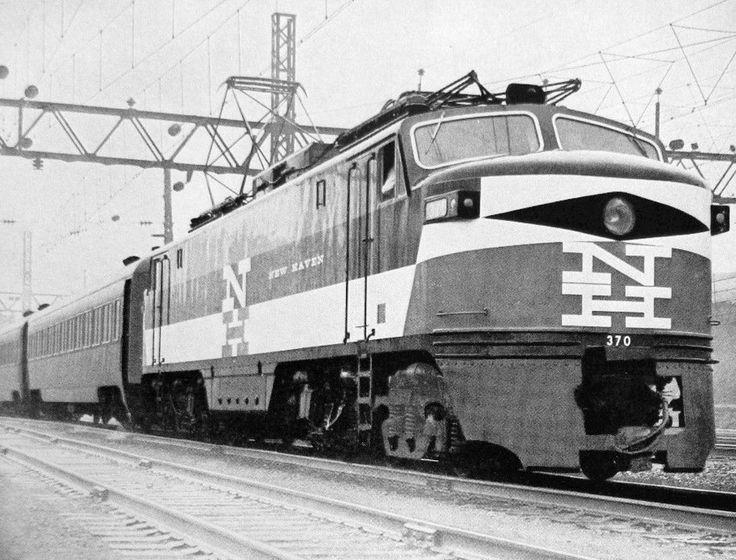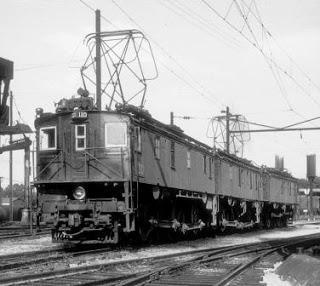The first image is the image on the left, the second image is the image on the right. Analyze the images presented: Is the assertion "in the image pair the trains are facing each other" valid? Answer yes or no. Yes. 